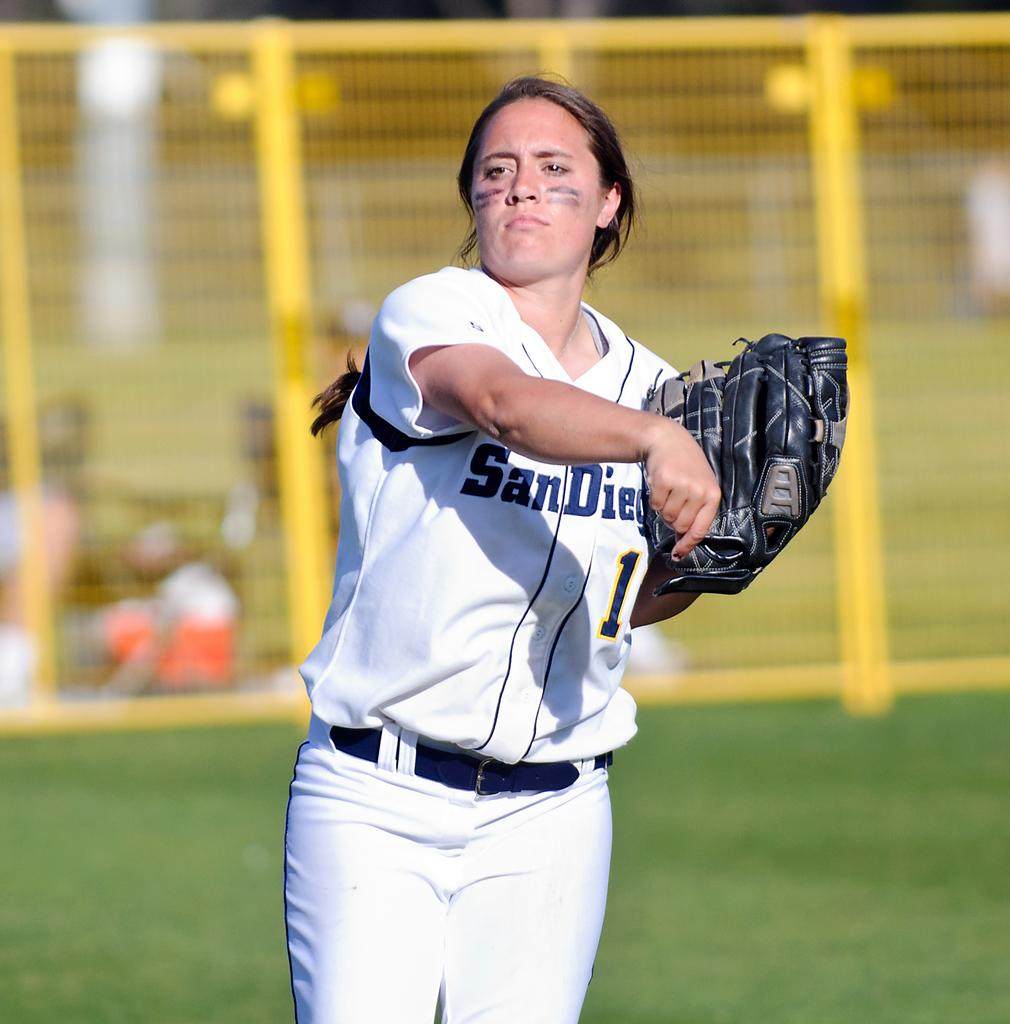<image>
Provide a brief description of the given image. a woman in a San Diego jersey with a black catchers mitt 